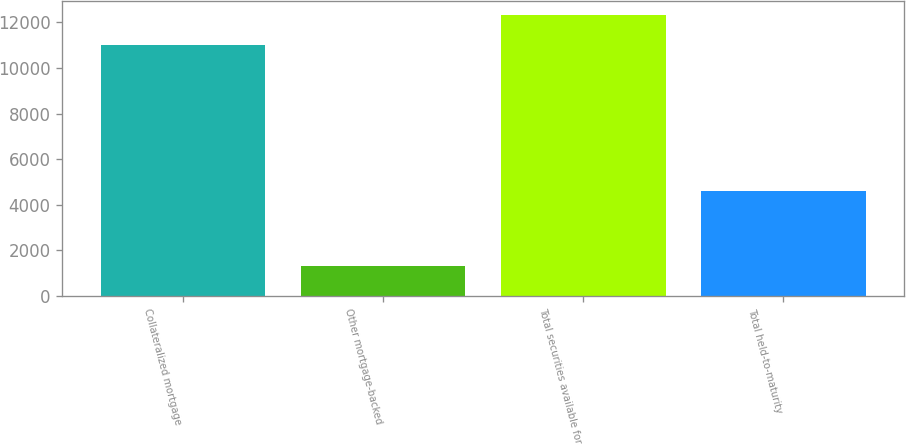<chart> <loc_0><loc_0><loc_500><loc_500><bar_chart><fcel>Collateralized mortgage<fcel>Other mortgage-backed<fcel>Total securities available for<fcel>Total held-to-maturity<nl><fcel>11000<fcel>1286<fcel>12346<fcel>4617<nl></chart> 